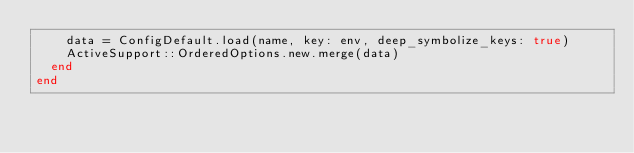Convert code to text. <code><loc_0><loc_0><loc_500><loc_500><_Ruby_>    data = ConfigDefault.load(name, key: env, deep_symbolize_keys: true)
    ActiveSupport::OrderedOptions.new.merge(data)
  end
end
</code> 